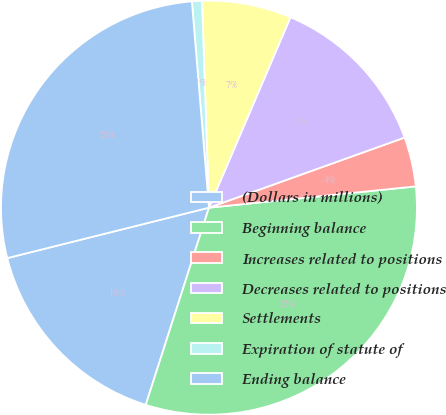Convert chart to OTSL. <chart><loc_0><loc_0><loc_500><loc_500><pie_chart><fcel>(Dollars in millions)<fcel>Beginning balance<fcel>Increases related to positions<fcel>Decreases related to positions<fcel>Settlements<fcel>Expiration of statute of<fcel>Ending balance<nl><fcel>16.17%<fcel>31.56%<fcel>3.86%<fcel>13.09%<fcel>6.94%<fcel>0.78%<fcel>27.61%<nl></chart> 